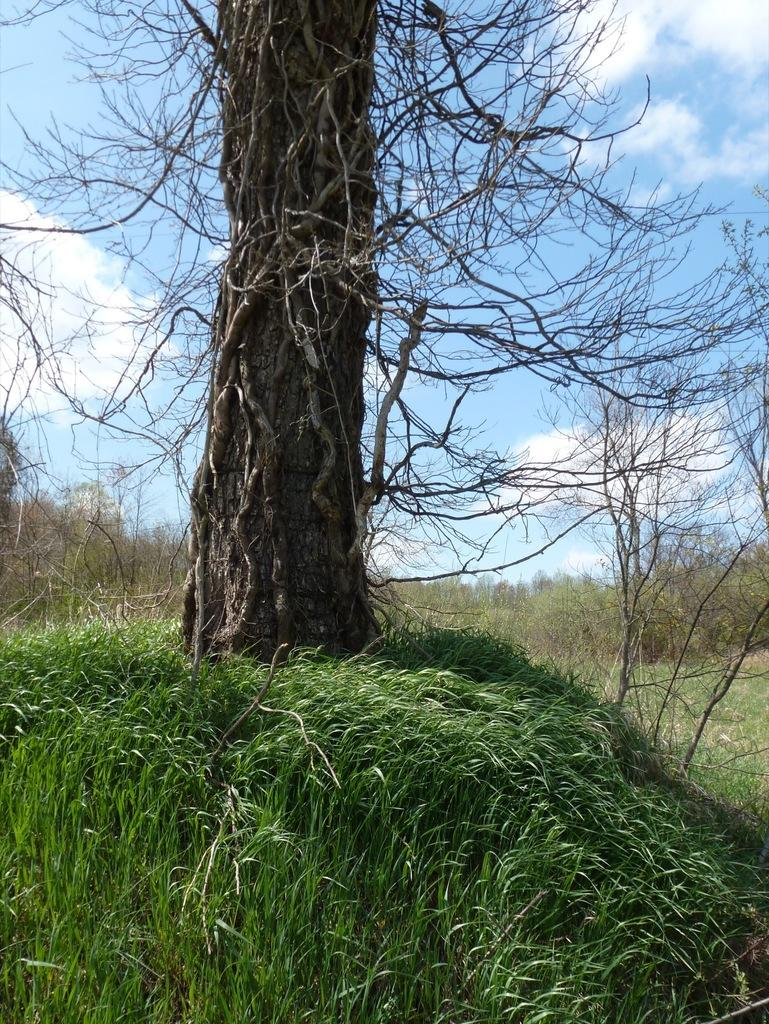What type of vegetation is present in the image? There is grass in the image. What other natural elements can be seen in the image? There are trees in the image. What is visible in the sky at the top of the image? There are clouds visible in the sky at the top of the image. What type of pump is used by the writer in the image? There is no pump or writer present in the image; it features grass, trees, and clouds. What kind of apparatus is being used by the writer in the image? There is no apparatus or writer present in the image. 